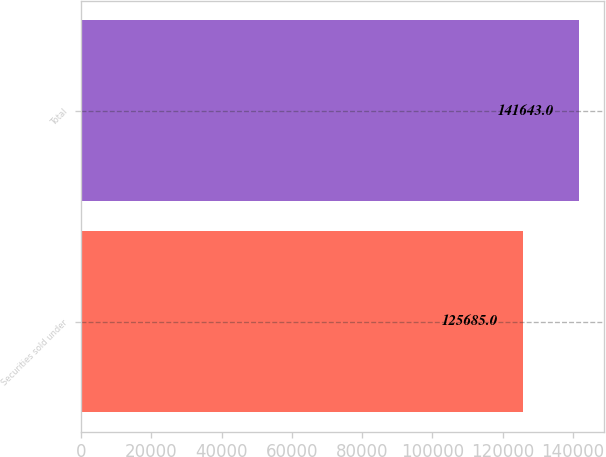Convert chart to OTSL. <chart><loc_0><loc_0><loc_500><loc_500><bar_chart><fcel>Securities sold under<fcel>Total<nl><fcel>125685<fcel>141643<nl></chart> 